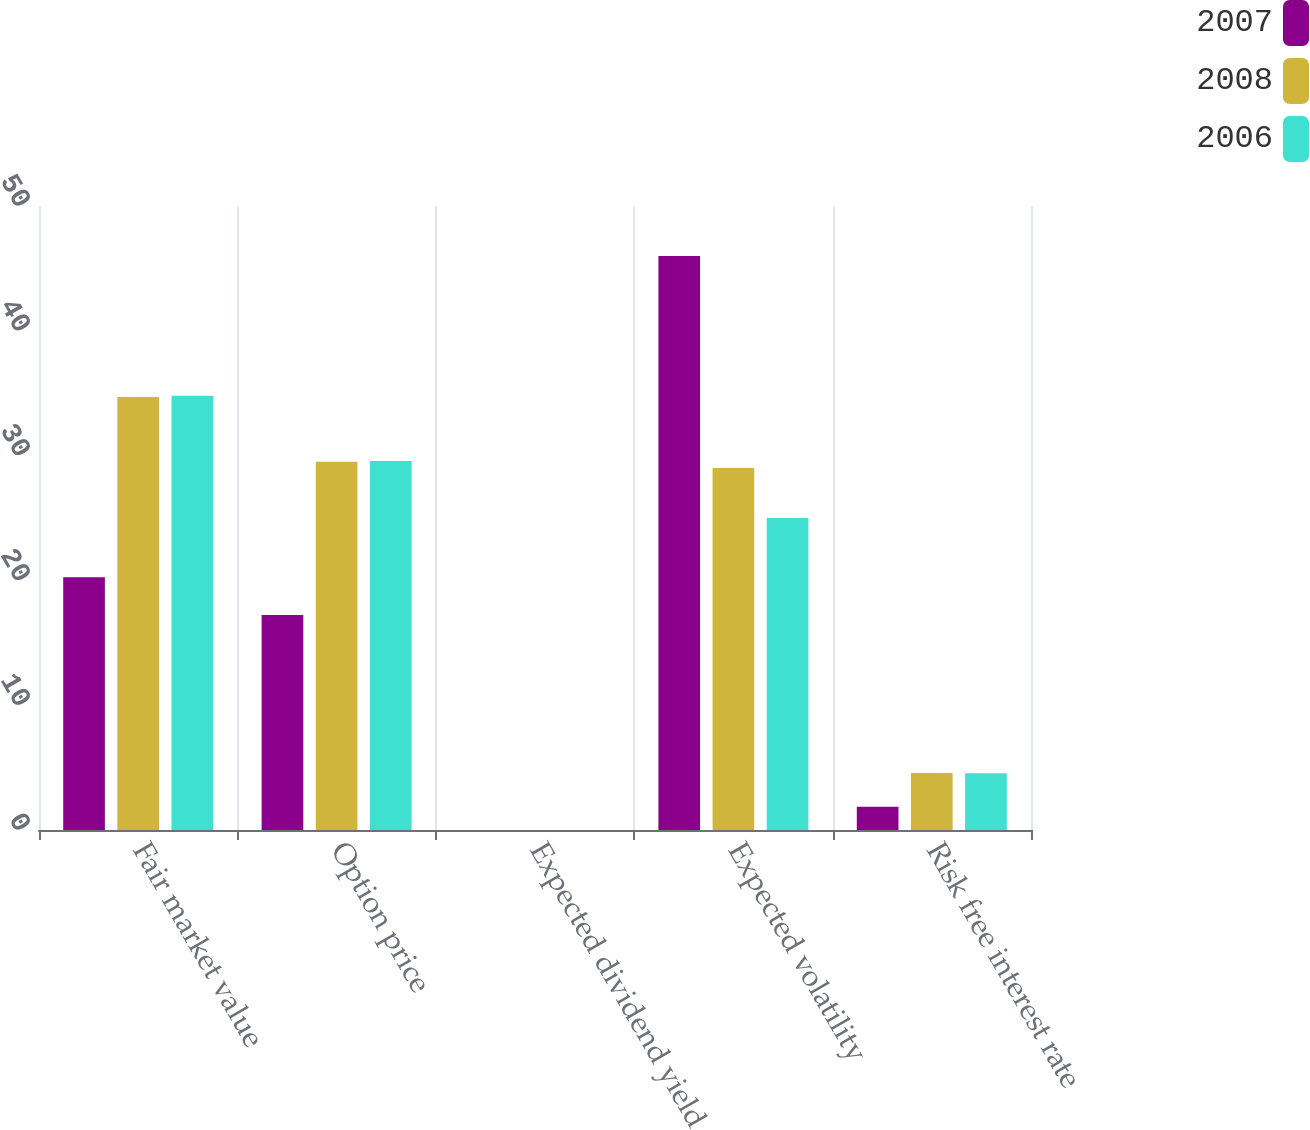<chart> <loc_0><loc_0><loc_500><loc_500><stacked_bar_chart><ecel><fcel>Fair market value<fcel>Option price<fcel>Expected dividend yield<fcel>Expected volatility<fcel>Risk free interest rate<nl><fcel>2007<fcel>20.26<fcel>17.22<fcel>0<fcel>46<fcel>1.87<nl><fcel>2008<fcel>34.7<fcel>29.5<fcel>0<fcel>29<fcel>4.57<nl><fcel>2006<fcel>34.79<fcel>29.57<fcel>0<fcel>25<fcel>4.54<nl></chart> 